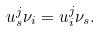<formula> <loc_0><loc_0><loc_500><loc_500>u ^ { j } _ { s } { \nu } _ { i } = u ^ { j } _ { i } { \nu } _ { s } .</formula> 